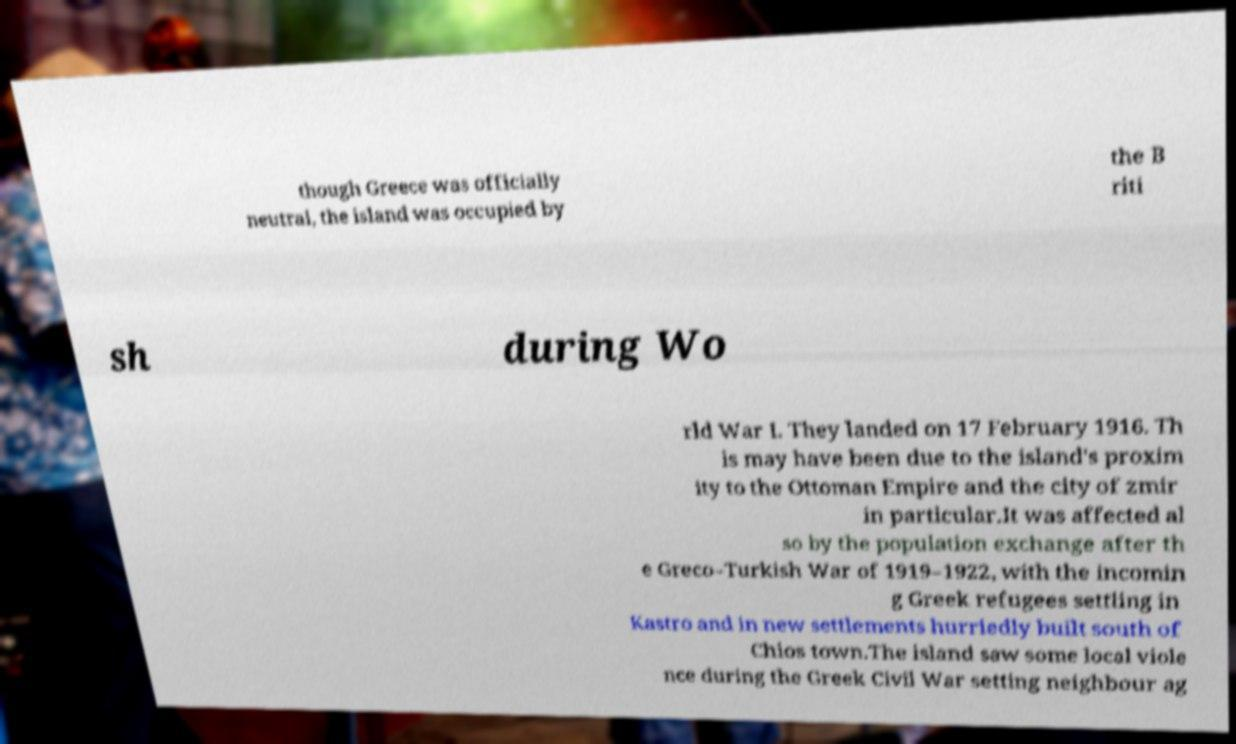Can you read and provide the text displayed in the image?This photo seems to have some interesting text. Can you extract and type it out for me? though Greece was officially neutral, the island was occupied by the B riti sh during Wo rld War I. They landed on 17 February 1916. Th is may have been due to the island's proxim ity to the Ottoman Empire and the city of zmir in particular.It was affected al so by the population exchange after th e Greco–Turkish War of 1919–1922, with the incomin g Greek refugees settling in Kastro and in new settlements hurriedly built south of Chios town.The island saw some local viole nce during the Greek Civil War setting neighbour ag 